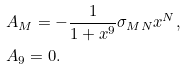Convert formula to latex. <formula><loc_0><loc_0><loc_500><loc_500>& A _ { M } = - \frac { 1 } { 1 + x ^ { 9 } } \sigma _ { M N } x ^ { N } , \\ & A _ { 9 } = 0 .</formula> 